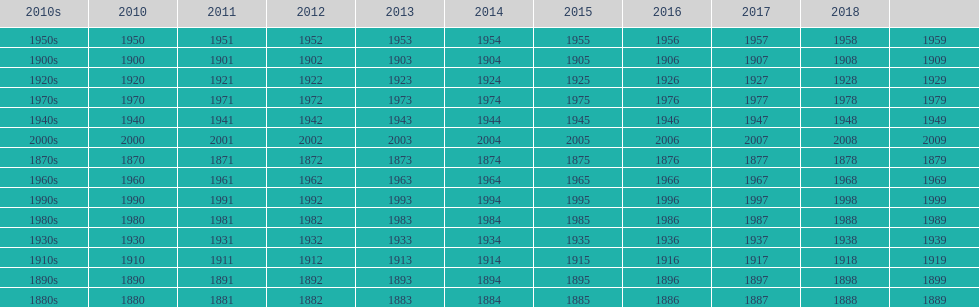True/false: all years go in consecutive order? True. 